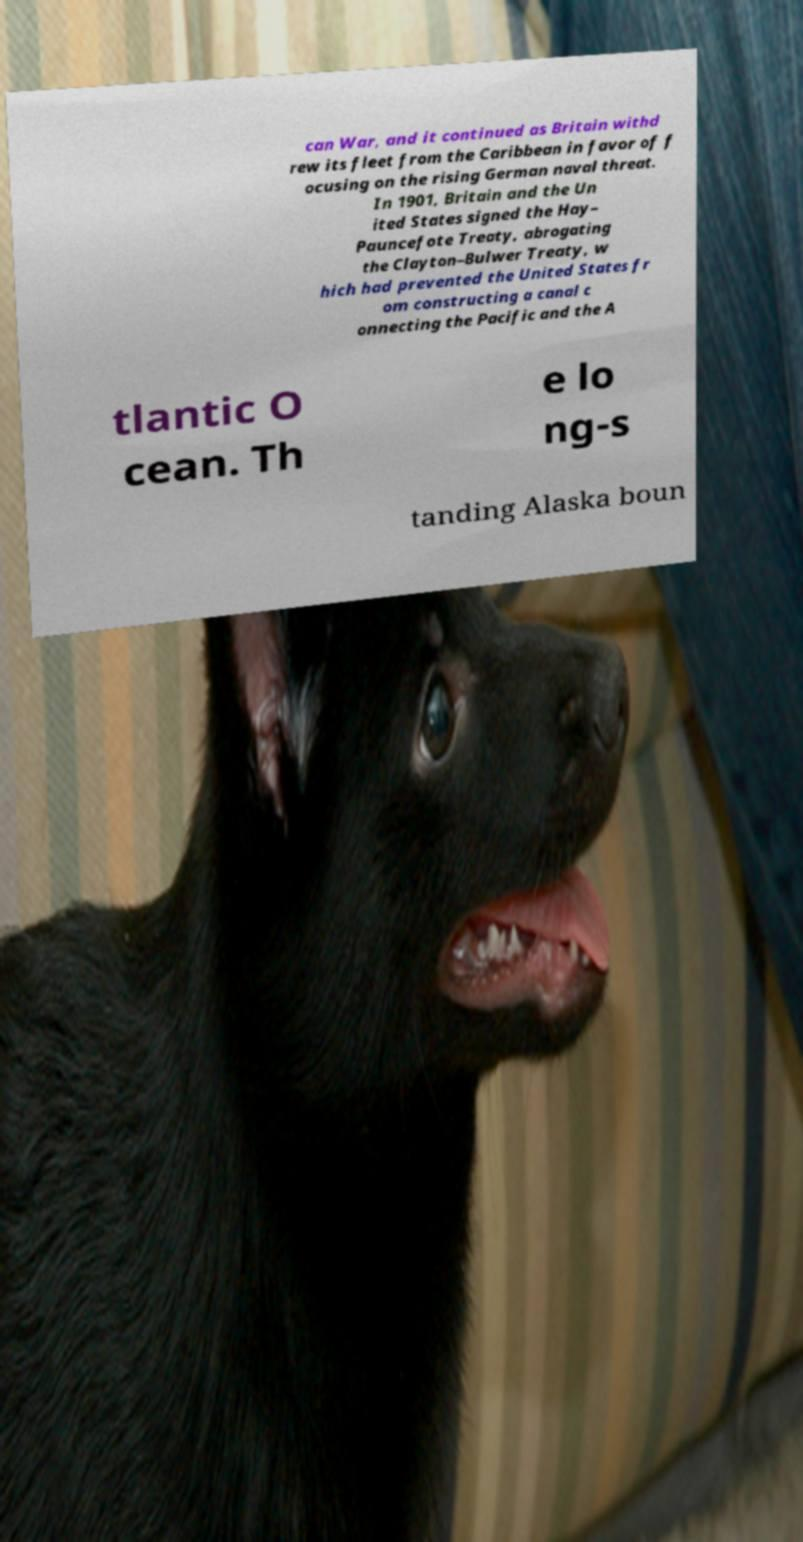For documentation purposes, I need the text within this image transcribed. Could you provide that? can War, and it continued as Britain withd rew its fleet from the Caribbean in favor of f ocusing on the rising German naval threat. In 1901, Britain and the Un ited States signed the Hay– Pauncefote Treaty, abrogating the Clayton–Bulwer Treaty, w hich had prevented the United States fr om constructing a canal c onnecting the Pacific and the A tlantic O cean. Th e lo ng-s tanding Alaska boun 